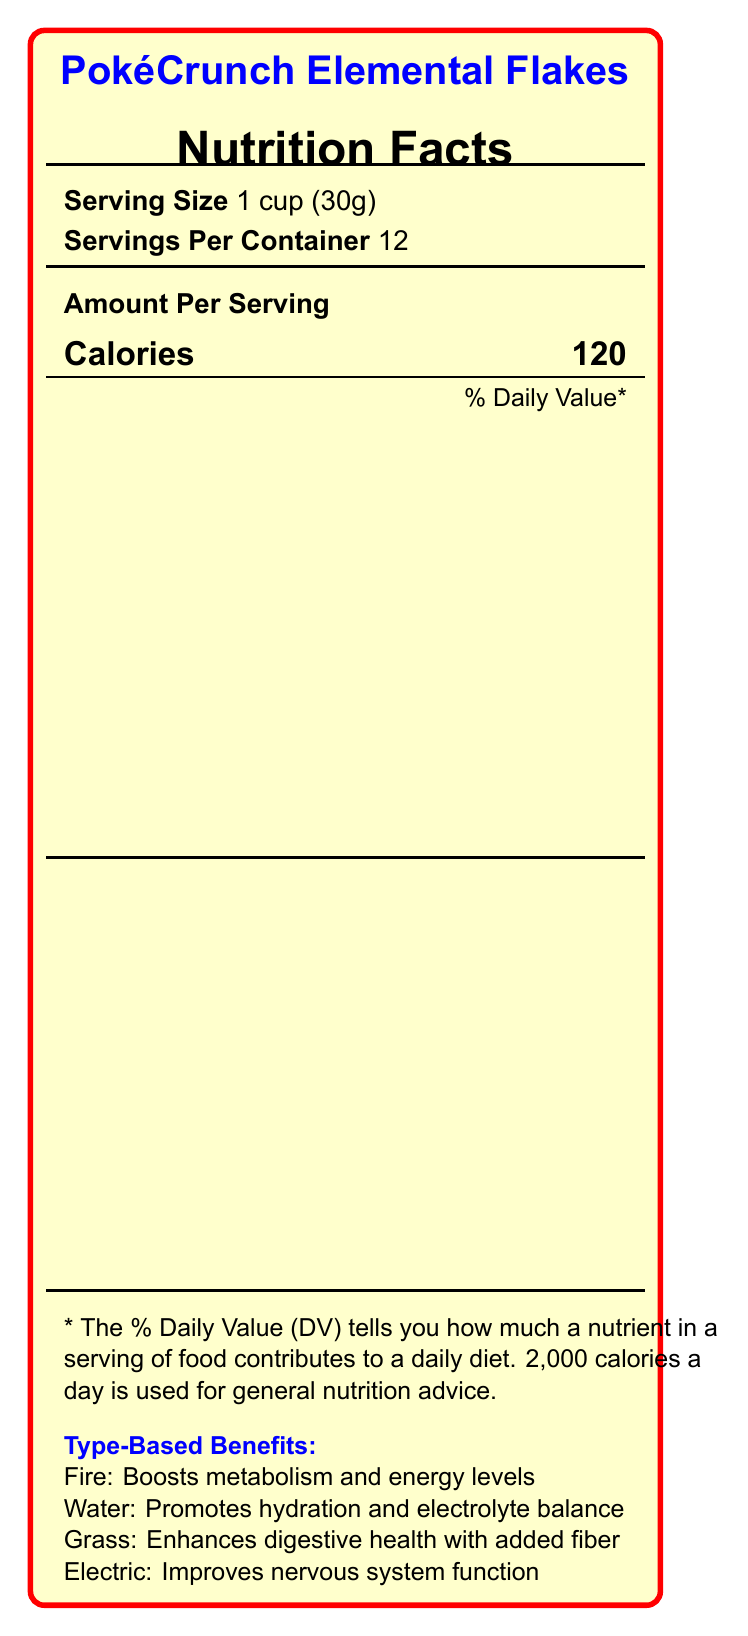what is the product name? The product name is listed at the top of the document as PokéCrunch Elemental Flakes.
Answer: PokéCrunch Elemental Flakes what is the serving size? The serving size is mentioned directly in the document as 1 cup (30g).
Answer: 1 cup (30g) how many calories are in one serving? The nutrition facts panel shows that one serving contains 120 calories.
Answer: 120 how many grams of total fat are in each serving? The document states that each serving contains 2 grams of total fat.
Answer: 2g what percent of the daily value of iron does one serving provide? The document mentions that one serving provides 35% of the daily value of iron.
Answer: 35% which type benefit is associated with improving nervous system function? The document lists Electric type benefits as improving nervous system function.
Answer: Electric which of the following ingredients is a preservative? A. Sugar B. Salt C. BHT D. Corn syrup The document details that BHT is used as a preservative in the ingredients list.
Answer: C what is the vitamin C content in one serving? A. 2mcg B. 1.5mcg C. 18mg D. 5mg The document shows that the vitamin C content per serving is 18mg.
Answer: C is PokéCrunch Elemental Flakes gluten-free? The ingredient list includes whole grain wheat, indicating that it is not gluten-free.
Answer: No list three vitamins present in PokéCrunch Elemental Flakes and their daily value percentages. The document lists Vitamin D at 10%, Niacin at 30%, and Vitamin B12 at 60% daily value.
Answer: Vitamin D (10%), Niacin (30%), Vitamin B12 (60%) does the product contain any dietary fiber? The document specifies that one serving contains 3 grams of dietary fiber, providing 11% of the daily value.
Answer: Yes what is the main idea of the document? The document focuses on presenting the nutritional information, benefits, ingredients, and allergen information of PokéCrunch Elemental Flakes.
Answer: The document provides detailed nutrition facts and ingredients for PokéCrunch Elemental Flakes cereal, highlighting its type-based benefits and daily value percentages of various nutrients. how long is the product shelf life? The shelf life of the product is not provided in the document.
Answer: Cannot be determined what is the manufacturer's name? The document mentions that the manufacturer is Silph Co. Foods.
Answer: Silph Co. Foods what is the benefit of the grass type ingredient in the cereal? The document lists that the grass type benefit entails enhancing digestive health with added fiber.
Answer: Enhances digestive health with added fiber 